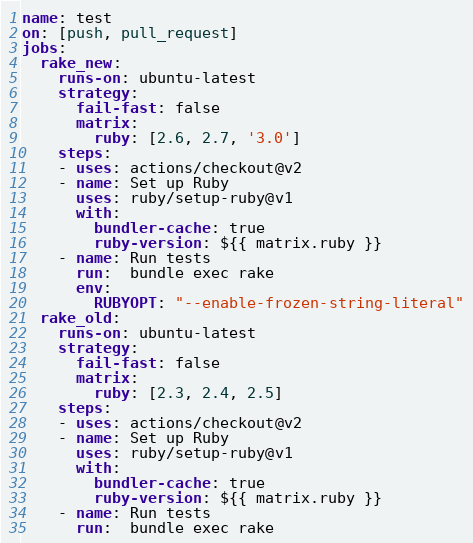Convert code to text. <code><loc_0><loc_0><loc_500><loc_500><_YAML_>name: test
on: [push, pull_request]
jobs:
  rake_new:
    runs-on: ubuntu-latest
    strategy:
      fail-fast: false
      matrix:
        ruby: [2.6, 2.7, '3.0']
    steps:
    - uses: actions/checkout@v2
    - name: Set up Ruby
      uses: ruby/setup-ruby@v1
      with:
        bundler-cache: true
        ruby-version: ${{ matrix.ruby }}
    - name: Run tests
      run:  bundle exec rake
      env:
        RUBYOPT: "--enable-frozen-string-literal"
  rake_old:
    runs-on: ubuntu-latest
    strategy:
      fail-fast: false
      matrix:
        ruby: [2.3, 2.4, 2.5]
    steps:
    - uses: actions/checkout@v2
    - name: Set up Ruby
      uses: ruby/setup-ruby@v1
      with:
        bundler-cache: true
        ruby-version: ${{ matrix.ruby }}
    - name: Run tests
      run:  bundle exec rake
</code> 